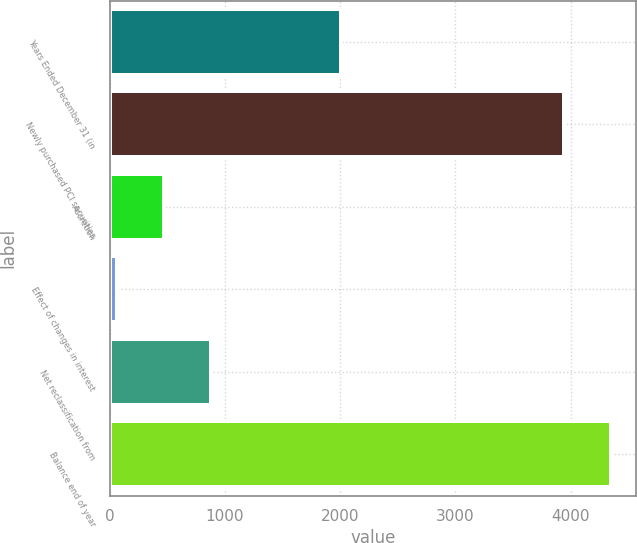Convert chart. <chart><loc_0><loc_0><loc_500><loc_500><bar_chart><fcel>Years Ended December 31 (in<fcel>Newly purchased PCI securities<fcel>Accretion<fcel>Effect of changes in interest<fcel>Net reclassification from<fcel>Balance end of year<nl><fcel>2011<fcel>3943<fcel>469.3<fcel>62<fcel>876.6<fcel>4350.3<nl></chart> 